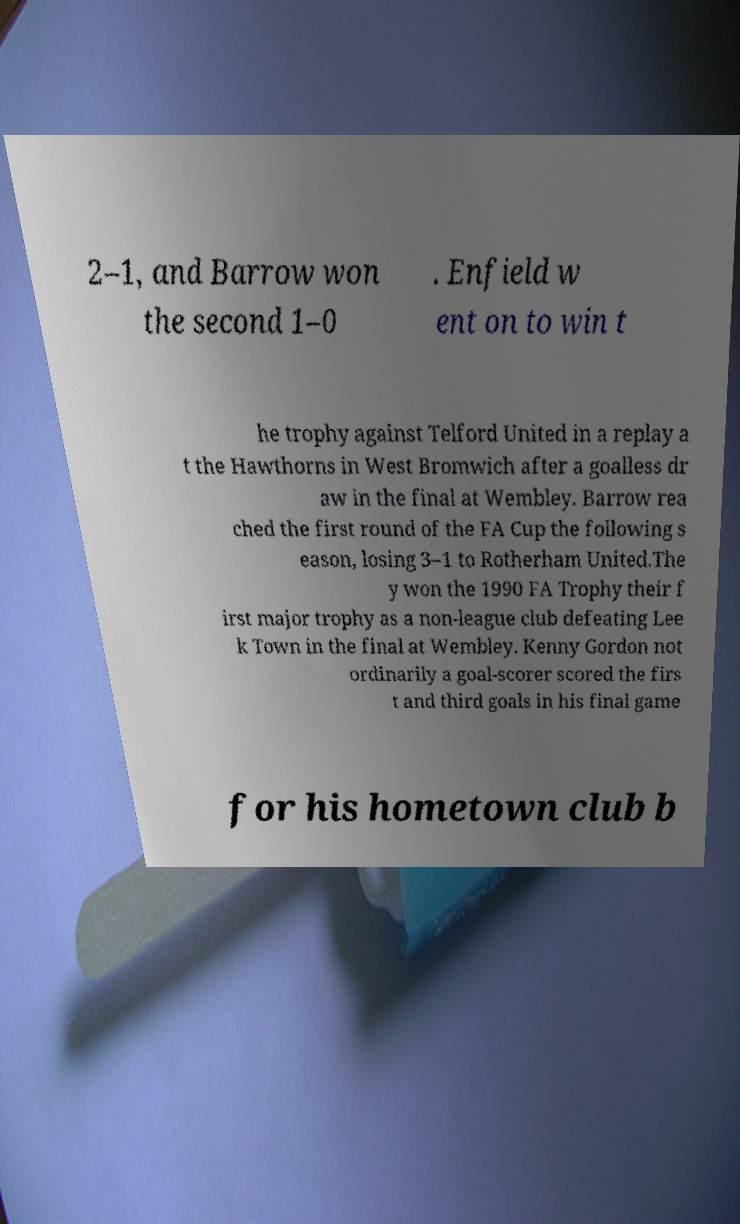There's text embedded in this image that I need extracted. Can you transcribe it verbatim? 2–1, and Barrow won the second 1–0 . Enfield w ent on to win t he trophy against Telford United in a replay a t the Hawthorns in West Bromwich after a goalless dr aw in the final at Wembley. Barrow rea ched the first round of the FA Cup the following s eason, losing 3–1 to Rotherham United.The y won the 1990 FA Trophy their f irst major trophy as a non-league club defeating Lee k Town in the final at Wembley. Kenny Gordon not ordinarily a goal-scorer scored the firs t and third goals in his final game for his hometown club b 